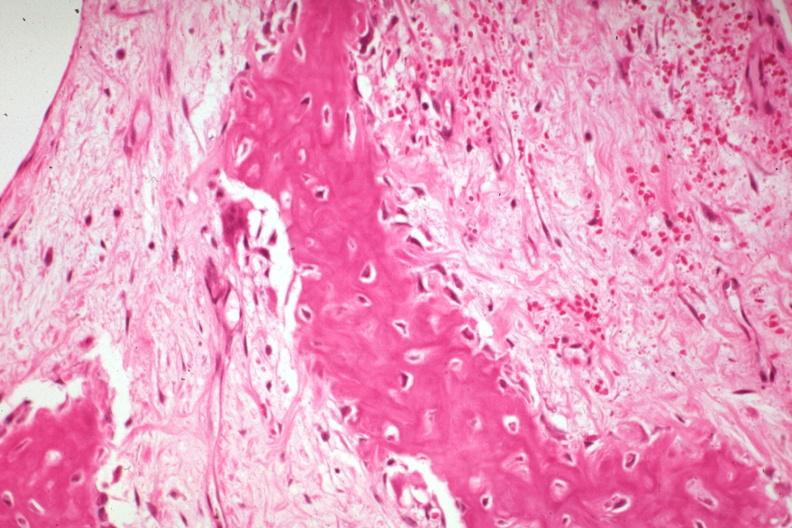does this image show high fibrous callus with osteoid and osteoblasts?
Answer the question using a single word or phrase. Yes 